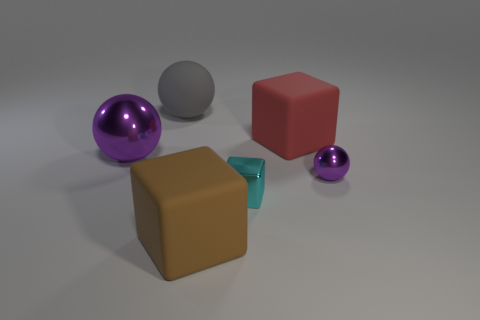Does the lighting of the scene suggest a particular time of day or setting? The lighting in the image is soft and diffuse, lacking harsh shadows or bright highlights. This suggests an indoor setting with controlled lighting. There's no indication of a specific time of day, given the lack of environmental context such as windows or natural light sources. 